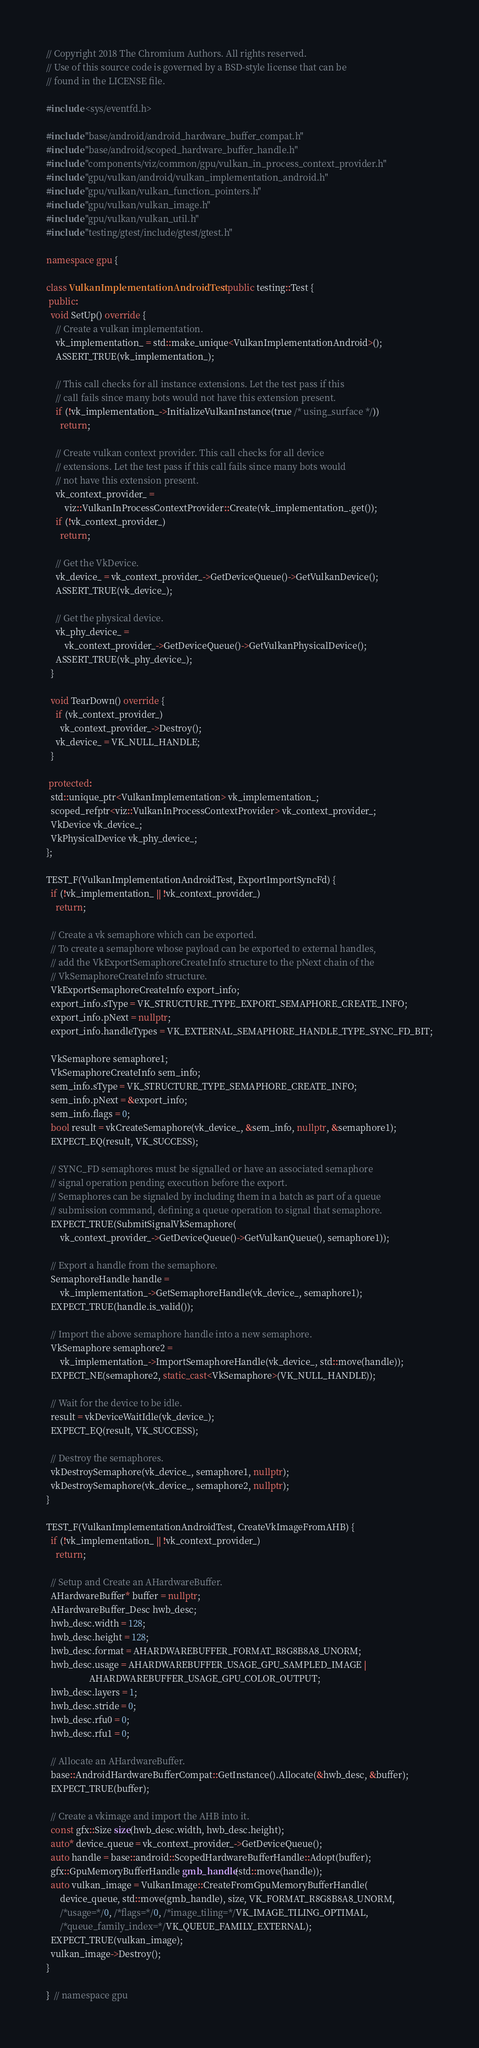<code> <loc_0><loc_0><loc_500><loc_500><_C++_>// Copyright 2018 The Chromium Authors. All rights reserved.
// Use of this source code is governed by a BSD-style license that can be
// found in the LICENSE file.

#include <sys/eventfd.h>

#include "base/android/android_hardware_buffer_compat.h"
#include "base/android/scoped_hardware_buffer_handle.h"
#include "components/viz/common/gpu/vulkan_in_process_context_provider.h"
#include "gpu/vulkan/android/vulkan_implementation_android.h"
#include "gpu/vulkan/vulkan_function_pointers.h"
#include "gpu/vulkan/vulkan_image.h"
#include "gpu/vulkan/vulkan_util.h"
#include "testing/gtest/include/gtest/gtest.h"

namespace gpu {

class VulkanImplementationAndroidTest : public testing::Test {
 public:
  void SetUp() override {
    // Create a vulkan implementation.
    vk_implementation_ = std::make_unique<VulkanImplementationAndroid>();
    ASSERT_TRUE(vk_implementation_);

    // This call checks for all instance extensions. Let the test pass if this
    // call fails since many bots would not have this extension present.
    if (!vk_implementation_->InitializeVulkanInstance(true /* using_surface */))
      return;

    // Create vulkan context provider. This call checks for all device
    // extensions. Let the test pass if this call fails since many bots would
    // not have this extension present.
    vk_context_provider_ =
        viz::VulkanInProcessContextProvider::Create(vk_implementation_.get());
    if (!vk_context_provider_)
      return;

    // Get the VkDevice.
    vk_device_ = vk_context_provider_->GetDeviceQueue()->GetVulkanDevice();
    ASSERT_TRUE(vk_device_);

    // Get the physical device.
    vk_phy_device_ =
        vk_context_provider_->GetDeviceQueue()->GetVulkanPhysicalDevice();
    ASSERT_TRUE(vk_phy_device_);
  }

  void TearDown() override {
    if (vk_context_provider_)
      vk_context_provider_->Destroy();
    vk_device_ = VK_NULL_HANDLE;
  }

 protected:
  std::unique_ptr<VulkanImplementation> vk_implementation_;
  scoped_refptr<viz::VulkanInProcessContextProvider> vk_context_provider_;
  VkDevice vk_device_;
  VkPhysicalDevice vk_phy_device_;
};

TEST_F(VulkanImplementationAndroidTest, ExportImportSyncFd) {
  if (!vk_implementation_ || !vk_context_provider_)
    return;

  // Create a vk semaphore which can be exported.
  // To create a semaphore whose payload can be exported to external handles,
  // add the VkExportSemaphoreCreateInfo structure to the pNext chain of the
  // VkSemaphoreCreateInfo structure.
  VkExportSemaphoreCreateInfo export_info;
  export_info.sType = VK_STRUCTURE_TYPE_EXPORT_SEMAPHORE_CREATE_INFO;
  export_info.pNext = nullptr;
  export_info.handleTypes = VK_EXTERNAL_SEMAPHORE_HANDLE_TYPE_SYNC_FD_BIT;

  VkSemaphore semaphore1;
  VkSemaphoreCreateInfo sem_info;
  sem_info.sType = VK_STRUCTURE_TYPE_SEMAPHORE_CREATE_INFO;
  sem_info.pNext = &export_info;
  sem_info.flags = 0;
  bool result = vkCreateSemaphore(vk_device_, &sem_info, nullptr, &semaphore1);
  EXPECT_EQ(result, VK_SUCCESS);

  // SYNC_FD semaphores must be signalled or have an associated semaphore
  // signal operation pending execution before the export.
  // Semaphores can be signaled by including them in a batch as part of a queue
  // submission command, defining a queue operation to signal that semaphore.
  EXPECT_TRUE(SubmitSignalVkSemaphore(
      vk_context_provider_->GetDeviceQueue()->GetVulkanQueue(), semaphore1));

  // Export a handle from the semaphore.
  SemaphoreHandle handle =
      vk_implementation_->GetSemaphoreHandle(vk_device_, semaphore1);
  EXPECT_TRUE(handle.is_valid());

  // Import the above semaphore handle into a new semaphore.
  VkSemaphore semaphore2 =
      vk_implementation_->ImportSemaphoreHandle(vk_device_, std::move(handle));
  EXPECT_NE(semaphore2, static_cast<VkSemaphore>(VK_NULL_HANDLE));

  // Wait for the device to be idle.
  result = vkDeviceWaitIdle(vk_device_);
  EXPECT_EQ(result, VK_SUCCESS);

  // Destroy the semaphores.
  vkDestroySemaphore(vk_device_, semaphore1, nullptr);
  vkDestroySemaphore(vk_device_, semaphore2, nullptr);
}

TEST_F(VulkanImplementationAndroidTest, CreateVkImageFromAHB) {
  if (!vk_implementation_ || !vk_context_provider_)
    return;

  // Setup and Create an AHardwareBuffer.
  AHardwareBuffer* buffer = nullptr;
  AHardwareBuffer_Desc hwb_desc;
  hwb_desc.width = 128;
  hwb_desc.height = 128;
  hwb_desc.format = AHARDWAREBUFFER_FORMAT_R8G8B8A8_UNORM;
  hwb_desc.usage = AHARDWAREBUFFER_USAGE_GPU_SAMPLED_IMAGE |
                   AHARDWAREBUFFER_USAGE_GPU_COLOR_OUTPUT;
  hwb_desc.layers = 1;
  hwb_desc.stride = 0;
  hwb_desc.rfu0 = 0;
  hwb_desc.rfu1 = 0;

  // Allocate an AHardwareBuffer.
  base::AndroidHardwareBufferCompat::GetInstance().Allocate(&hwb_desc, &buffer);
  EXPECT_TRUE(buffer);

  // Create a vkimage and import the AHB into it.
  const gfx::Size size(hwb_desc.width, hwb_desc.height);
  auto* device_queue = vk_context_provider_->GetDeviceQueue();
  auto handle = base::android::ScopedHardwareBufferHandle::Adopt(buffer);
  gfx::GpuMemoryBufferHandle gmb_handle(std::move(handle));
  auto vulkan_image = VulkanImage::CreateFromGpuMemoryBufferHandle(
      device_queue, std::move(gmb_handle), size, VK_FORMAT_R8G8B8A8_UNORM,
      /*usage=*/0, /*flags=*/0, /*image_tiling=*/VK_IMAGE_TILING_OPTIMAL,
      /*queue_family_index=*/VK_QUEUE_FAMILY_EXTERNAL);
  EXPECT_TRUE(vulkan_image);
  vulkan_image->Destroy();
}

}  // namespace gpu
</code> 